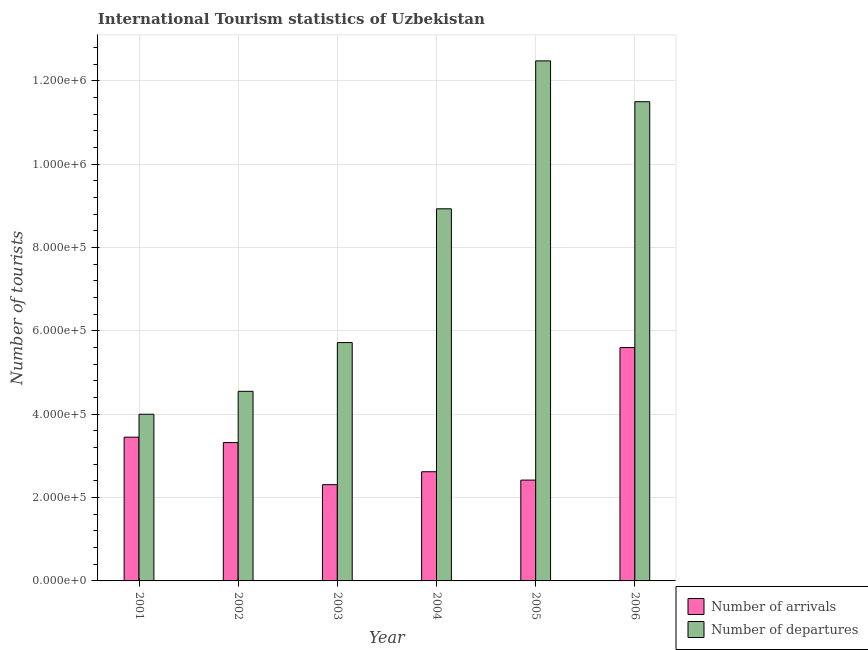How many different coloured bars are there?
Your response must be concise. 2. Are the number of bars per tick equal to the number of legend labels?
Give a very brief answer. Yes. Are the number of bars on each tick of the X-axis equal?
Your answer should be very brief. Yes. In how many cases, is the number of bars for a given year not equal to the number of legend labels?
Offer a terse response. 0. What is the number of tourist departures in 2004?
Your answer should be very brief. 8.93e+05. Across all years, what is the maximum number of tourist arrivals?
Ensure brevity in your answer.  5.60e+05. Across all years, what is the minimum number of tourist arrivals?
Keep it short and to the point. 2.31e+05. What is the total number of tourist departures in the graph?
Your response must be concise. 4.72e+06. What is the difference between the number of tourist arrivals in 2001 and that in 2002?
Your answer should be compact. 1.30e+04. What is the difference between the number of tourist arrivals in 2006 and the number of tourist departures in 2002?
Provide a short and direct response. 2.28e+05. What is the average number of tourist arrivals per year?
Give a very brief answer. 3.29e+05. In the year 2001, what is the difference between the number of tourist arrivals and number of tourist departures?
Keep it short and to the point. 0. In how many years, is the number of tourist departures greater than 440000?
Your answer should be compact. 5. What is the ratio of the number of tourist arrivals in 2003 to that in 2004?
Provide a short and direct response. 0.88. Is the difference between the number of tourist arrivals in 2001 and 2004 greater than the difference between the number of tourist departures in 2001 and 2004?
Make the answer very short. No. What is the difference between the highest and the second highest number of tourist arrivals?
Offer a very short reply. 2.15e+05. What is the difference between the highest and the lowest number of tourist arrivals?
Ensure brevity in your answer.  3.29e+05. In how many years, is the number of tourist arrivals greater than the average number of tourist arrivals taken over all years?
Provide a short and direct response. 3. What does the 2nd bar from the left in 2001 represents?
Give a very brief answer. Number of departures. What does the 2nd bar from the right in 2001 represents?
Give a very brief answer. Number of arrivals. Are all the bars in the graph horizontal?
Ensure brevity in your answer.  No. How many years are there in the graph?
Give a very brief answer. 6. Does the graph contain any zero values?
Keep it short and to the point. No. Does the graph contain grids?
Make the answer very short. No. Where does the legend appear in the graph?
Your response must be concise. Bottom left. How many legend labels are there?
Your answer should be very brief. 2. How are the legend labels stacked?
Offer a very short reply. Horizontal. What is the title of the graph?
Make the answer very short. International Tourism statistics of Uzbekistan. Does "Diarrhea" appear as one of the legend labels in the graph?
Provide a short and direct response. No. What is the label or title of the X-axis?
Your answer should be compact. Year. What is the label or title of the Y-axis?
Provide a short and direct response. Number of tourists. What is the Number of tourists in Number of arrivals in 2001?
Your response must be concise. 3.45e+05. What is the Number of tourists of Number of departures in 2001?
Your answer should be very brief. 4.00e+05. What is the Number of tourists of Number of arrivals in 2002?
Make the answer very short. 3.32e+05. What is the Number of tourists of Number of departures in 2002?
Ensure brevity in your answer.  4.55e+05. What is the Number of tourists of Number of arrivals in 2003?
Offer a terse response. 2.31e+05. What is the Number of tourists in Number of departures in 2003?
Offer a very short reply. 5.72e+05. What is the Number of tourists of Number of arrivals in 2004?
Your answer should be very brief. 2.62e+05. What is the Number of tourists of Number of departures in 2004?
Ensure brevity in your answer.  8.93e+05. What is the Number of tourists of Number of arrivals in 2005?
Give a very brief answer. 2.42e+05. What is the Number of tourists of Number of departures in 2005?
Offer a terse response. 1.25e+06. What is the Number of tourists in Number of arrivals in 2006?
Give a very brief answer. 5.60e+05. What is the Number of tourists in Number of departures in 2006?
Your answer should be compact. 1.15e+06. Across all years, what is the maximum Number of tourists in Number of arrivals?
Offer a very short reply. 5.60e+05. Across all years, what is the maximum Number of tourists of Number of departures?
Keep it short and to the point. 1.25e+06. Across all years, what is the minimum Number of tourists in Number of arrivals?
Give a very brief answer. 2.31e+05. Across all years, what is the minimum Number of tourists in Number of departures?
Your response must be concise. 4.00e+05. What is the total Number of tourists in Number of arrivals in the graph?
Ensure brevity in your answer.  1.97e+06. What is the total Number of tourists in Number of departures in the graph?
Your answer should be compact. 4.72e+06. What is the difference between the Number of tourists of Number of arrivals in 2001 and that in 2002?
Give a very brief answer. 1.30e+04. What is the difference between the Number of tourists in Number of departures in 2001 and that in 2002?
Your answer should be very brief. -5.50e+04. What is the difference between the Number of tourists in Number of arrivals in 2001 and that in 2003?
Your answer should be compact. 1.14e+05. What is the difference between the Number of tourists in Number of departures in 2001 and that in 2003?
Provide a succinct answer. -1.72e+05. What is the difference between the Number of tourists of Number of arrivals in 2001 and that in 2004?
Ensure brevity in your answer.  8.30e+04. What is the difference between the Number of tourists of Number of departures in 2001 and that in 2004?
Offer a very short reply. -4.93e+05. What is the difference between the Number of tourists in Number of arrivals in 2001 and that in 2005?
Provide a succinct answer. 1.03e+05. What is the difference between the Number of tourists in Number of departures in 2001 and that in 2005?
Keep it short and to the point. -8.48e+05. What is the difference between the Number of tourists in Number of arrivals in 2001 and that in 2006?
Offer a very short reply. -2.15e+05. What is the difference between the Number of tourists of Number of departures in 2001 and that in 2006?
Keep it short and to the point. -7.50e+05. What is the difference between the Number of tourists in Number of arrivals in 2002 and that in 2003?
Ensure brevity in your answer.  1.01e+05. What is the difference between the Number of tourists of Number of departures in 2002 and that in 2003?
Offer a terse response. -1.17e+05. What is the difference between the Number of tourists of Number of departures in 2002 and that in 2004?
Offer a very short reply. -4.38e+05. What is the difference between the Number of tourists in Number of departures in 2002 and that in 2005?
Offer a terse response. -7.93e+05. What is the difference between the Number of tourists in Number of arrivals in 2002 and that in 2006?
Ensure brevity in your answer.  -2.28e+05. What is the difference between the Number of tourists in Number of departures in 2002 and that in 2006?
Your response must be concise. -6.95e+05. What is the difference between the Number of tourists of Number of arrivals in 2003 and that in 2004?
Give a very brief answer. -3.10e+04. What is the difference between the Number of tourists in Number of departures in 2003 and that in 2004?
Your answer should be very brief. -3.21e+05. What is the difference between the Number of tourists of Number of arrivals in 2003 and that in 2005?
Offer a very short reply. -1.10e+04. What is the difference between the Number of tourists in Number of departures in 2003 and that in 2005?
Offer a terse response. -6.76e+05. What is the difference between the Number of tourists in Number of arrivals in 2003 and that in 2006?
Offer a very short reply. -3.29e+05. What is the difference between the Number of tourists in Number of departures in 2003 and that in 2006?
Your answer should be compact. -5.78e+05. What is the difference between the Number of tourists in Number of departures in 2004 and that in 2005?
Give a very brief answer. -3.55e+05. What is the difference between the Number of tourists in Number of arrivals in 2004 and that in 2006?
Ensure brevity in your answer.  -2.98e+05. What is the difference between the Number of tourists in Number of departures in 2004 and that in 2006?
Offer a very short reply. -2.57e+05. What is the difference between the Number of tourists of Number of arrivals in 2005 and that in 2006?
Provide a short and direct response. -3.18e+05. What is the difference between the Number of tourists of Number of departures in 2005 and that in 2006?
Your response must be concise. 9.80e+04. What is the difference between the Number of tourists of Number of arrivals in 2001 and the Number of tourists of Number of departures in 2003?
Your answer should be very brief. -2.27e+05. What is the difference between the Number of tourists in Number of arrivals in 2001 and the Number of tourists in Number of departures in 2004?
Your answer should be very brief. -5.48e+05. What is the difference between the Number of tourists of Number of arrivals in 2001 and the Number of tourists of Number of departures in 2005?
Keep it short and to the point. -9.03e+05. What is the difference between the Number of tourists in Number of arrivals in 2001 and the Number of tourists in Number of departures in 2006?
Your response must be concise. -8.05e+05. What is the difference between the Number of tourists of Number of arrivals in 2002 and the Number of tourists of Number of departures in 2003?
Make the answer very short. -2.40e+05. What is the difference between the Number of tourists of Number of arrivals in 2002 and the Number of tourists of Number of departures in 2004?
Make the answer very short. -5.61e+05. What is the difference between the Number of tourists of Number of arrivals in 2002 and the Number of tourists of Number of departures in 2005?
Provide a succinct answer. -9.16e+05. What is the difference between the Number of tourists of Number of arrivals in 2002 and the Number of tourists of Number of departures in 2006?
Give a very brief answer. -8.18e+05. What is the difference between the Number of tourists of Number of arrivals in 2003 and the Number of tourists of Number of departures in 2004?
Ensure brevity in your answer.  -6.62e+05. What is the difference between the Number of tourists of Number of arrivals in 2003 and the Number of tourists of Number of departures in 2005?
Your response must be concise. -1.02e+06. What is the difference between the Number of tourists of Number of arrivals in 2003 and the Number of tourists of Number of departures in 2006?
Make the answer very short. -9.19e+05. What is the difference between the Number of tourists of Number of arrivals in 2004 and the Number of tourists of Number of departures in 2005?
Provide a succinct answer. -9.86e+05. What is the difference between the Number of tourists in Number of arrivals in 2004 and the Number of tourists in Number of departures in 2006?
Give a very brief answer. -8.88e+05. What is the difference between the Number of tourists of Number of arrivals in 2005 and the Number of tourists of Number of departures in 2006?
Your answer should be very brief. -9.08e+05. What is the average Number of tourists of Number of arrivals per year?
Provide a succinct answer. 3.29e+05. What is the average Number of tourists of Number of departures per year?
Give a very brief answer. 7.86e+05. In the year 2001, what is the difference between the Number of tourists of Number of arrivals and Number of tourists of Number of departures?
Your answer should be very brief. -5.50e+04. In the year 2002, what is the difference between the Number of tourists of Number of arrivals and Number of tourists of Number of departures?
Offer a very short reply. -1.23e+05. In the year 2003, what is the difference between the Number of tourists in Number of arrivals and Number of tourists in Number of departures?
Give a very brief answer. -3.41e+05. In the year 2004, what is the difference between the Number of tourists in Number of arrivals and Number of tourists in Number of departures?
Make the answer very short. -6.31e+05. In the year 2005, what is the difference between the Number of tourists of Number of arrivals and Number of tourists of Number of departures?
Give a very brief answer. -1.01e+06. In the year 2006, what is the difference between the Number of tourists of Number of arrivals and Number of tourists of Number of departures?
Provide a short and direct response. -5.90e+05. What is the ratio of the Number of tourists in Number of arrivals in 2001 to that in 2002?
Offer a terse response. 1.04. What is the ratio of the Number of tourists of Number of departures in 2001 to that in 2002?
Ensure brevity in your answer.  0.88. What is the ratio of the Number of tourists in Number of arrivals in 2001 to that in 2003?
Provide a succinct answer. 1.49. What is the ratio of the Number of tourists in Number of departures in 2001 to that in 2003?
Make the answer very short. 0.7. What is the ratio of the Number of tourists in Number of arrivals in 2001 to that in 2004?
Keep it short and to the point. 1.32. What is the ratio of the Number of tourists of Number of departures in 2001 to that in 2004?
Give a very brief answer. 0.45. What is the ratio of the Number of tourists in Number of arrivals in 2001 to that in 2005?
Provide a succinct answer. 1.43. What is the ratio of the Number of tourists in Number of departures in 2001 to that in 2005?
Offer a terse response. 0.32. What is the ratio of the Number of tourists in Number of arrivals in 2001 to that in 2006?
Your answer should be very brief. 0.62. What is the ratio of the Number of tourists in Number of departures in 2001 to that in 2006?
Keep it short and to the point. 0.35. What is the ratio of the Number of tourists in Number of arrivals in 2002 to that in 2003?
Give a very brief answer. 1.44. What is the ratio of the Number of tourists in Number of departures in 2002 to that in 2003?
Your answer should be very brief. 0.8. What is the ratio of the Number of tourists of Number of arrivals in 2002 to that in 2004?
Your answer should be compact. 1.27. What is the ratio of the Number of tourists in Number of departures in 2002 to that in 2004?
Provide a short and direct response. 0.51. What is the ratio of the Number of tourists in Number of arrivals in 2002 to that in 2005?
Give a very brief answer. 1.37. What is the ratio of the Number of tourists of Number of departures in 2002 to that in 2005?
Your answer should be compact. 0.36. What is the ratio of the Number of tourists in Number of arrivals in 2002 to that in 2006?
Ensure brevity in your answer.  0.59. What is the ratio of the Number of tourists in Number of departures in 2002 to that in 2006?
Make the answer very short. 0.4. What is the ratio of the Number of tourists of Number of arrivals in 2003 to that in 2004?
Keep it short and to the point. 0.88. What is the ratio of the Number of tourists of Number of departures in 2003 to that in 2004?
Offer a very short reply. 0.64. What is the ratio of the Number of tourists in Number of arrivals in 2003 to that in 2005?
Ensure brevity in your answer.  0.95. What is the ratio of the Number of tourists in Number of departures in 2003 to that in 2005?
Keep it short and to the point. 0.46. What is the ratio of the Number of tourists in Number of arrivals in 2003 to that in 2006?
Provide a short and direct response. 0.41. What is the ratio of the Number of tourists of Number of departures in 2003 to that in 2006?
Provide a short and direct response. 0.5. What is the ratio of the Number of tourists of Number of arrivals in 2004 to that in 2005?
Make the answer very short. 1.08. What is the ratio of the Number of tourists of Number of departures in 2004 to that in 2005?
Provide a short and direct response. 0.72. What is the ratio of the Number of tourists of Number of arrivals in 2004 to that in 2006?
Offer a terse response. 0.47. What is the ratio of the Number of tourists in Number of departures in 2004 to that in 2006?
Offer a terse response. 0.78. What is the ratio of the Number of tourists of Number of arrivals in 2005 to that in 2006?
Give a very brief answer. 0.43. What is the ratio of the Number of tourists of Number of departures in 2005 to that in 2006?
Offer a very short reply. 1.09. What is the difference between the highest and the second highest Number of tourists of Number of arrivals?
Your answer should be compact. 2.15e+05. What is the difference between the highest and the second highest Number of tourists of Number of departures?
Keep it short and to the point. 9.80e+04. What is the difference between the highest and the lowest Number of tourists of Number of arrivals?
Offer a very short reply. 3.29e+05. What is the difference between the highest and the lowest Number of tourists in Number of departures?
Offer a terse response. 8.48e+05. 